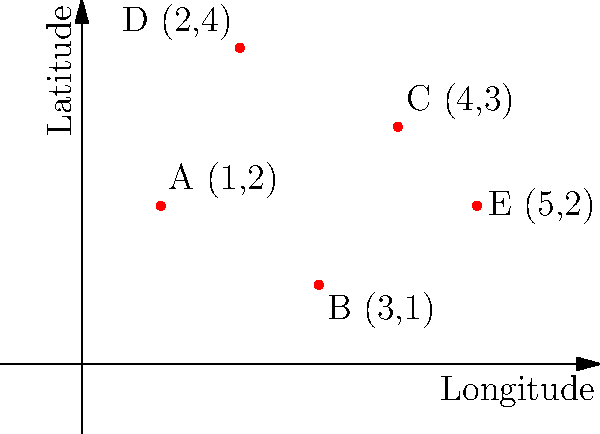The map above shows the locations of five refugee-owned enterprises (A, B, C, D, and E) plotted on a coordinate system where the x-axis represents longitude and the y-axis represents latitude. If you were to draw a line connecting the two enterprises that are furthest apart, what would be the length of this line? To find the length of the line connecting the two furthest enterprises, we need to:

1. Calculate the distance between each pair of points using the distance formula:
   $d = \sqrt{(x_2 - x_1)^2 + (y_2 - y_1)^2}$

2. Compare these distances to find the maximum.

Let's calculate:

AB: $\sqrt{(3-1)^2 + (1-2)^2} = \sqrt{4 + 1} = \sqrt{5}$
AC: $\sqrt{(4-1)^2 + (3-2)^2} = \sqrt{9 + 1} = \sqrt{10}$
AD: $\sqrt{(2-1)^2 + (4-2)^2} = \sqrt{1 + 4} = \sqrt{5}$
AE: $\sqrt{(5-1)^2 + (2-2)^2} = \sqrt{16 + 0} = 4$
BC: $\sqrt{(4-3)^2 + (3-1)^2} = \sqrt{1 + 4} = \sqrt{5}$
BD: $\sqrt{(2-3)^2 + (4-1)^2} = \sqrt{1 + 9} = \sqrt{10}$
BE: $\sqrt{(5-3)^2 + (2-1)^2} = \sqrt{4 + 1} = \sqrt{5}$
CD: $\sqrt{(2-4)^2 + (4-3)^2} = \sqrt{4 + 1} = \sqrt{5}$
CE: $\sqrt{(5-4)^2 + (2-3)^2} = \sqrt{1 + 1} = \sqrt{2}$
DE: $\sqrt{(5-2)^2 + (2-4)^2} = \sqrt{9 + 4} = \sqrt{13}$

The maximum distance is $\sqrt{13}$, which occurs between points D and E.
Answer: $\sqrt{13}$ 